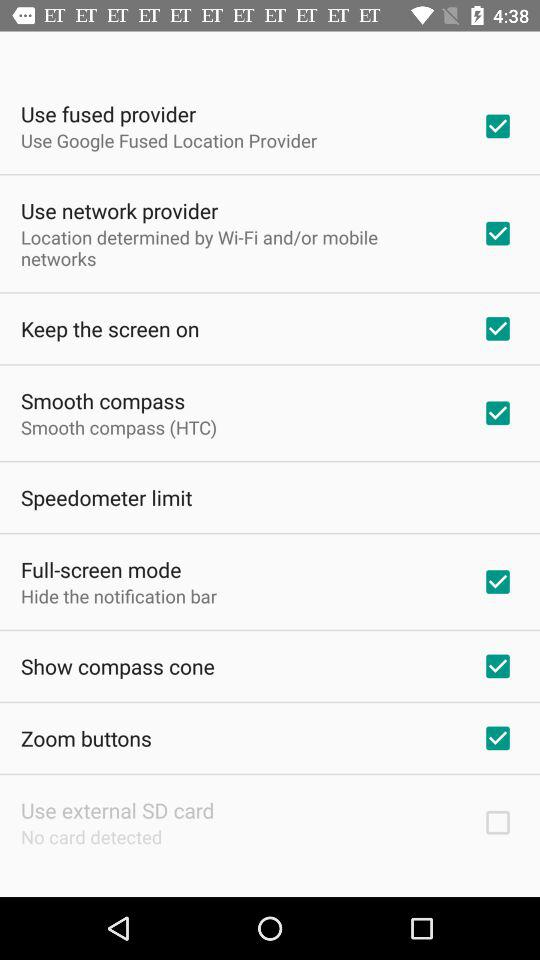Which check box is unchecked? The check box, which is unchecked, is "Use external SD card". 